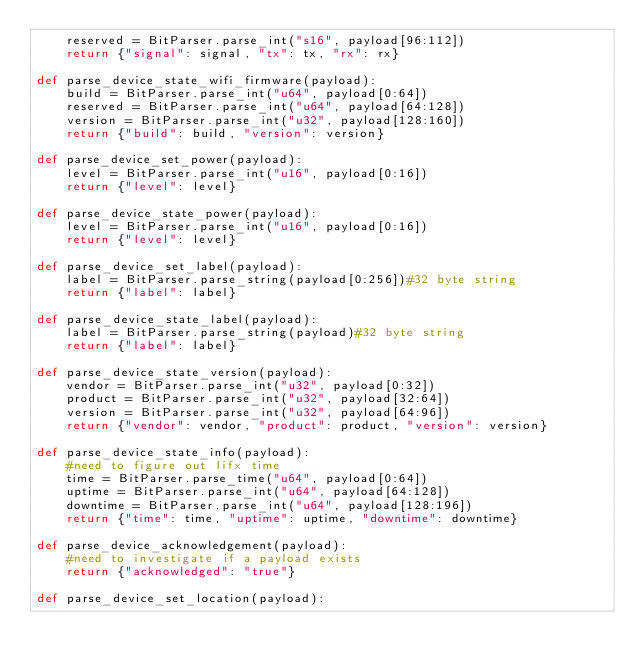<code> <loc_0><loc_0><loc_500><loc_500><_Python_>    reserved = BitParser.parse_int("s16", payload[96:112])
    return {"signal": signal, "tx": tx, "rx": rx}

def parse_device_state_wifi_firmware(payload):
    build = BitParser.parse_int("u64", payload[0:64])
    reserved = BitParser.parse_int("u64", payload[64:128])
    version = BitParser.parse_int("u32", payload[128:160])
    return {"build": build, "version": version}

def parse_device_set_power(payload):
    level = BitParser.parse_int("u16", payload[0:16])
    return {"level": level}

def parse_device_state_power(payload):
    level = BitParser.parse_int("u16", payload[0:16])
    return {"level": level}

def parse_device_set_label(payload):
    label = BitParser.parse_string(payload[0:256])#32 byte string
    return {"label": label}

def parse_device_state_label(payload):
    label = BitParser.parse_string(payload)#32 byte string
    return {"label": label}

def parse_device_state_version(payload):
    vendor = BitParser.parse_int("u32", payload[0:32])
    product = BitParser.parse_int("u32", payload[32:64])
    version = BitParser.parse_int("u32", payload[64:96])
    return {"vendor": vendor, "product": product, "version": version}

def parse_device_state_info(payload):
    #need to figure out lifx time
    time = BitParser.parse_time("u64", payload[0:64])
    uptime = BitParser.parse_int("u64", payload[64:128])
    downtime = BitParser.parse_int("u64", payload[128:196])
    return {"time": time, "uptime": uptime, "downtime": downtime}

def parse_device_acknowledgement(payload):
    #need to investigate if a payload exists
    return {"acknowledged": "true"}

def parse_device_set_location(payload):</code> 